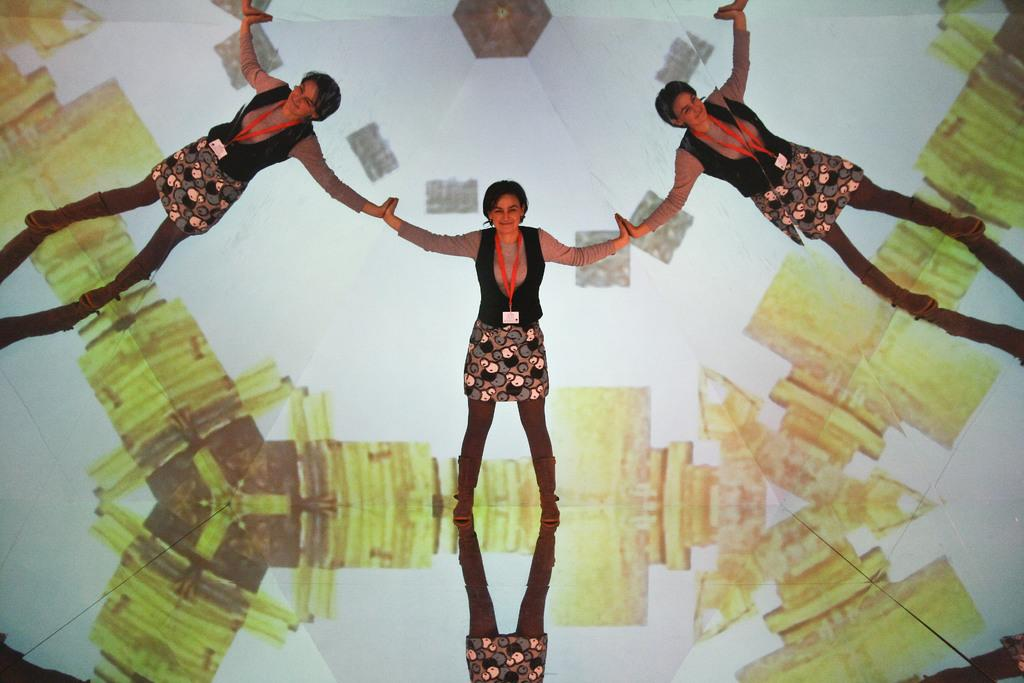What is the main subject of the image? There is a woman in the image. What is the woman doing in the image? The woman is standing and smiling. Where is the woman located in the image? The woman is in the center of the image. What type of pin can be seen in the woman's hair in the image? There is no pin visible in the woman's hair in the image. How does the woman lift heavy objects in the image? The image does not show the woman lifting heavy objects; she is simply standing and smiling. 